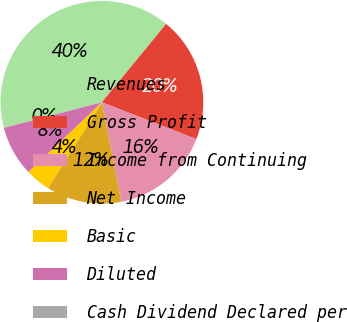Convert chart. <chart><loc_0><loc_0><loc_500><loc_500><pie_chart><fcel>Revenues<fcel>Gross Profit<fcel>Income from Continuing<fcel>Net Income<fcel>Basic<fcel>Diluted<fcel>Cash Dividend Declared per<nl><fcel>40.0%<fcel>20.0%<fcel>16.0%<fcel>12.0%<fcel>4.0%<fcel>8.0%<fcel>0.0%<nl></chart> 